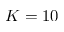Convert formula to latex. <formula><loc_0><loc_0><loc_500><loc_500>K = 1 0</formula> 